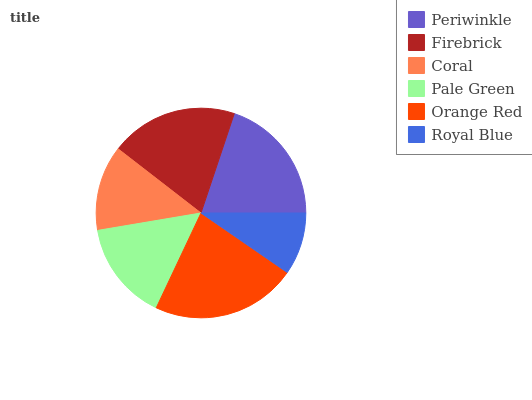Is Royal Blue the minimum?
Answer yes or no. Yes. Is Orange Red the maximum?
Answer yes or no. Yes. Is Firebrick the minimum?
Answer yes or no. No. Is Firebrick the maximum?
Answer yes or no. No. Is Periwinkle greater than Firebrick?
Answer yes or no. Yes. Is Firebrick less than Periwinkle?
Answer yes or no. Yes. Is Firebrick greater than Periwinkle?
Answer yes or no. No. Is Periwinkle less than Firebrick?
Answer yes or no. No. Is Firebrick the high median?
Answer yes or no. Yes. Is Pale Green the low median?
Answer yes or no. Yes. Is Periwinkle the high median?
Answer yes or no. No. Is Orange Red the low median?
Answer yes or no. No. 